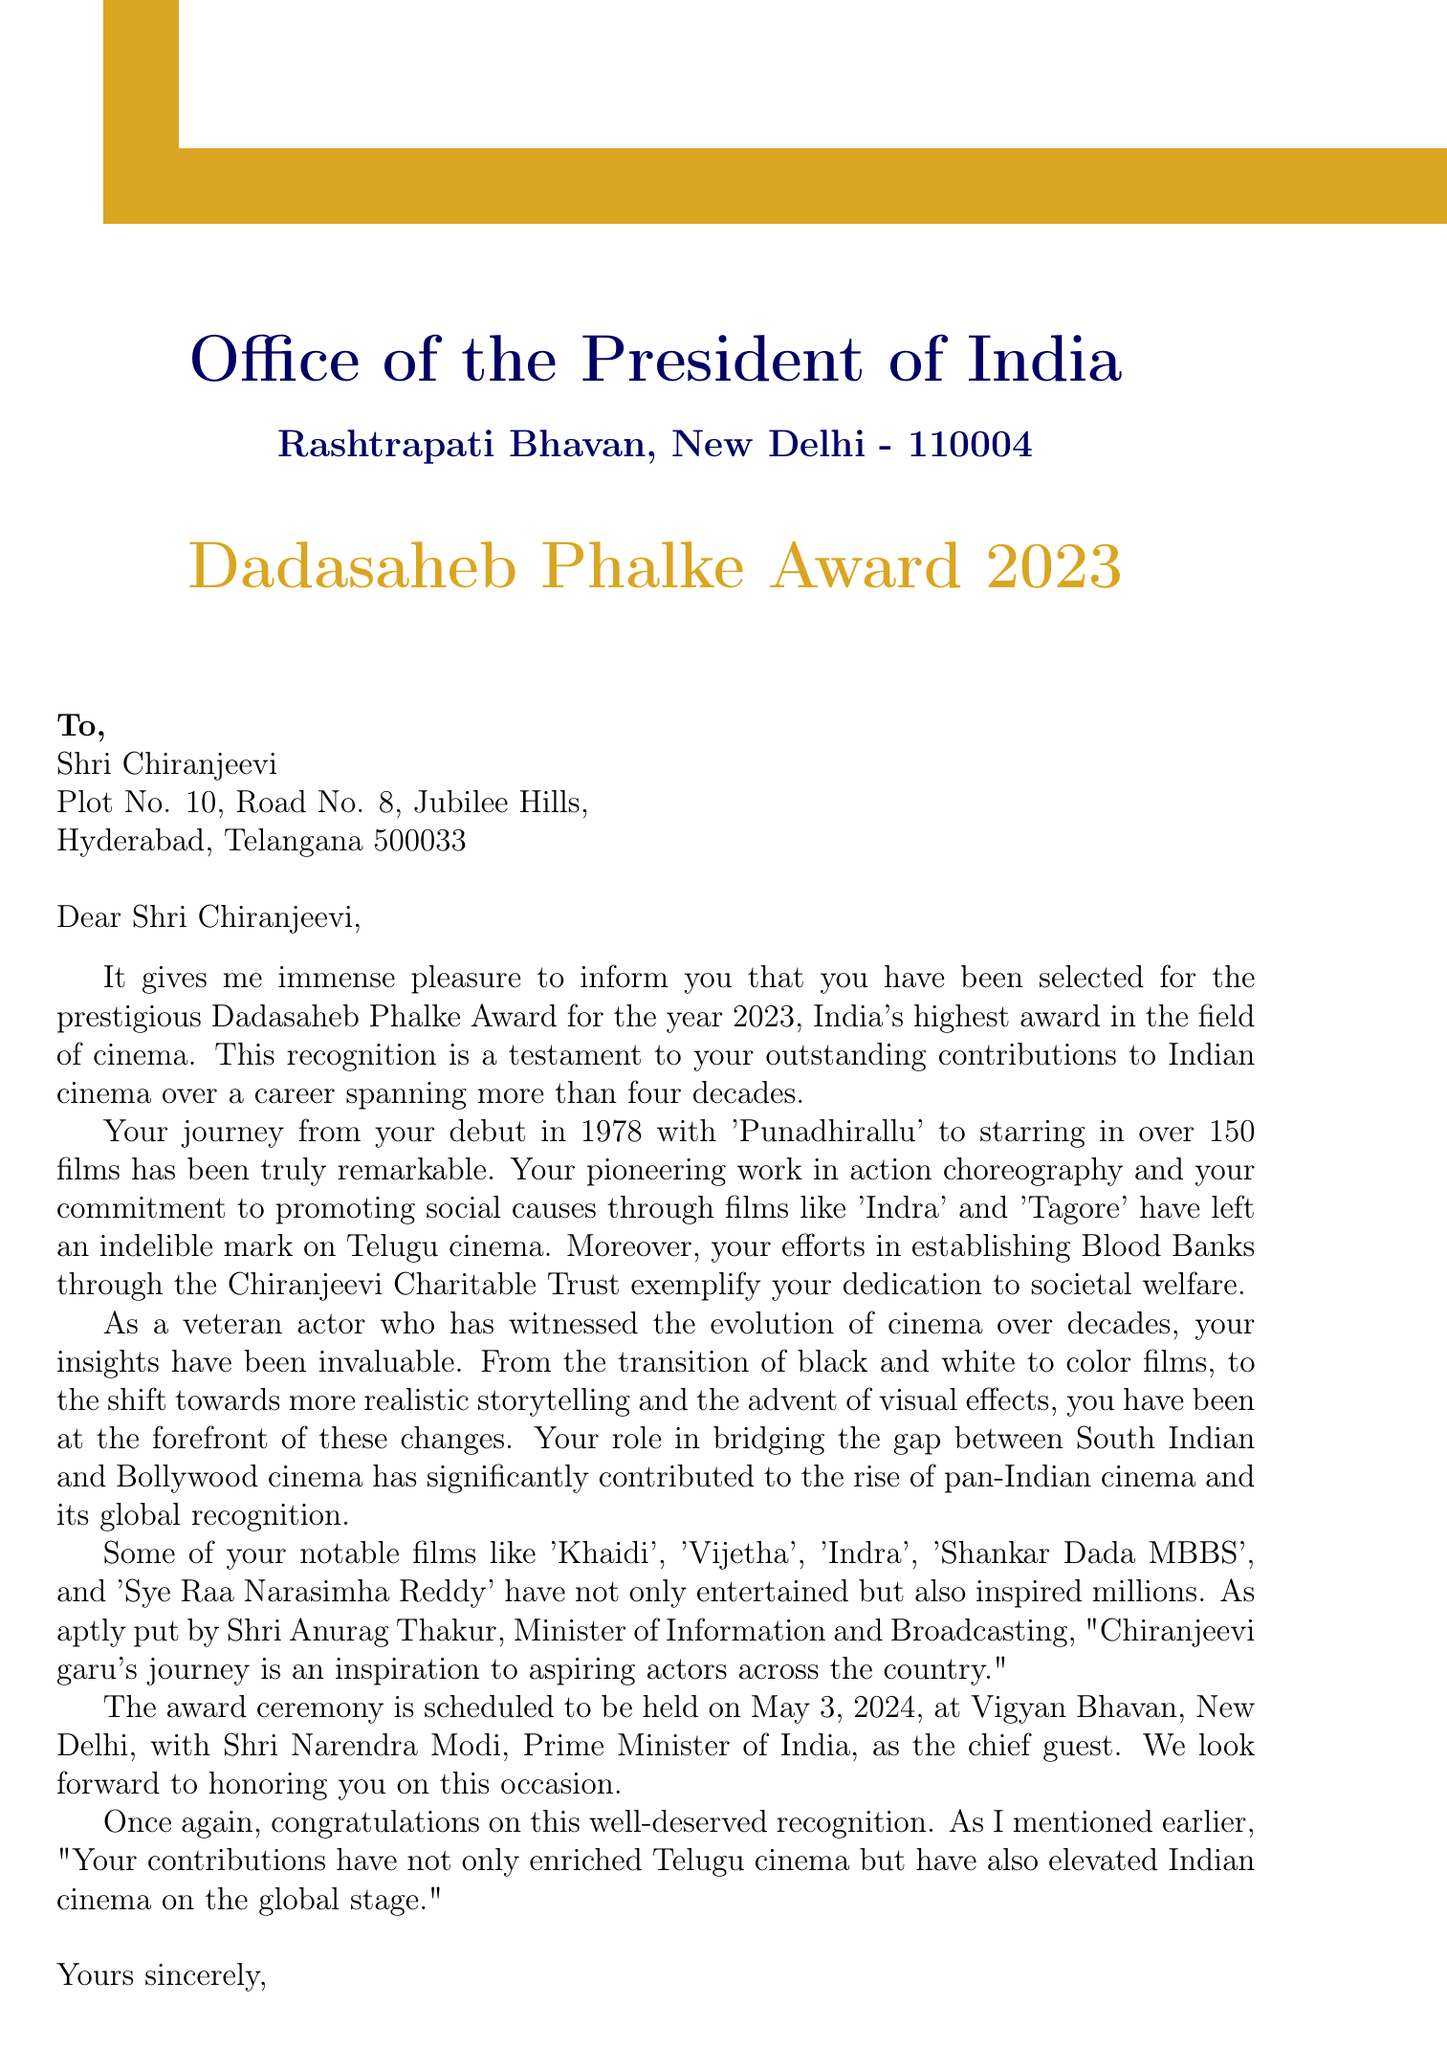What is the name of the award? The award mentioned in the document is the highest honor in the cinema field, known as the Dadasaheb Phalke Award.
Answer: Dadasaheb Phalke Award Who is the sender of the letter? The sender of the letter is identified as Smt. Droupadi Murmu, the President of India.
Answer: Smt. Droupadi Murmu In which year did Chiranjeevi make his film debut? The debut year can be found in the career highlights section, which notes that it occurred in 1978.
Answer: 1978 What will be the date of the award ceremony? The document specifies the award ceremony is scheduled for May 3, 2024.
Answer: May 3, 2024 Which film is mentioned as part of Chiranjeevi's notable films? The document lists several films, including 'Indra', as part of notable works by Chiranjeevi.
Answer: Indra Who will be the chief guest at the award ceremony? This information can be found in the award ceremony details stating that the Prime Minister of India will attend.
Answer: Shri Narendra Modi What is the purpose of the letter? The primary purpose detailed in the document is to congratulate Chiranjeevi on receiving a prestigious cinema award.
Answer: Congratulatory letter Which social cause has Chiranjeevi contributed to? The document outlines specific contributions, including establishing Blood Banks through his charitable trust.
Answer: Blood Banks What is one change in cinema highlighted in the document? The document discusses several evolution aspects, one being the transition from black and white to color films.
Answer: Transition from black and white to color films 